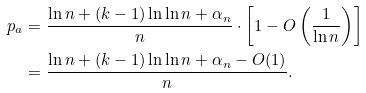<formula> <loc_0><loc_0><loc_500><loc_500>p _ { a } & = \frac { \ln n + { ( k - 1 ) } \ln \ln n + { \alpha _ { n } } } { n } \cdot \left [ 1 - O \left ( \frac { 1 } { \ln n } \right ) \right ] \\ & = \frac { \ln n + { ( k - 1 ) } \ln \ln n + { \alpha _ { n } } - O ( 1 ) } { n } .</formula> 